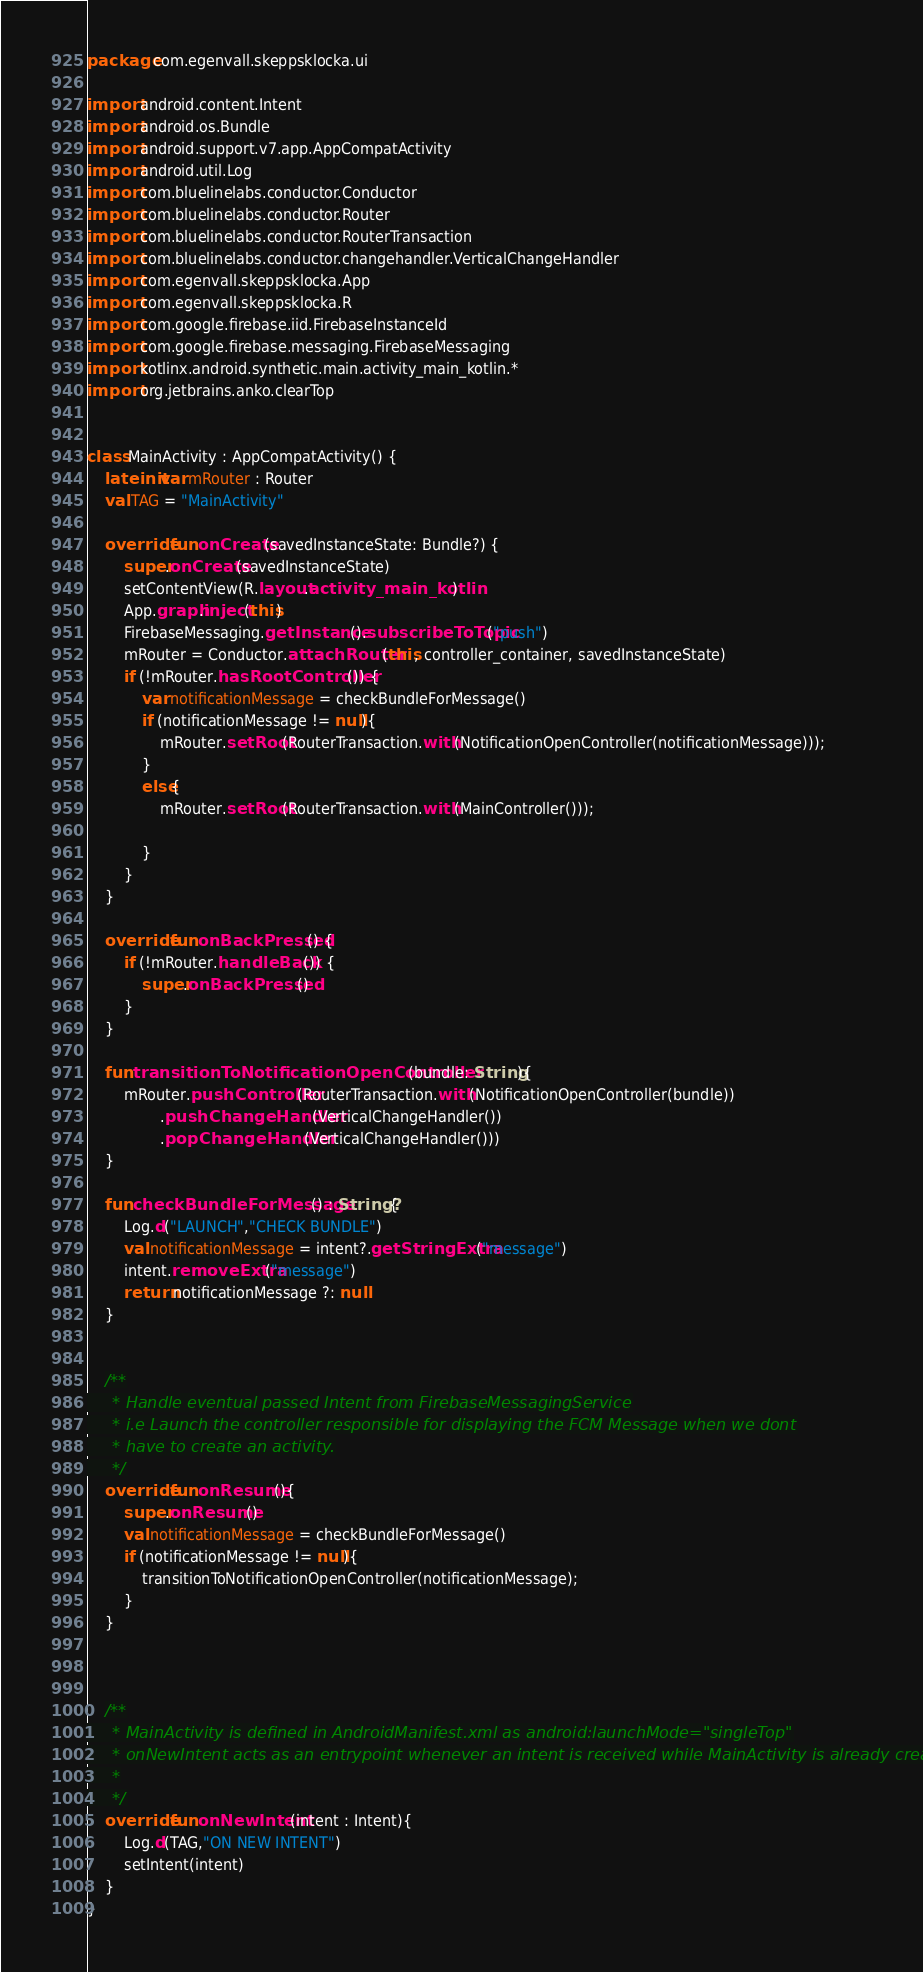<code> <loc_0><loc_0><loc_500><loc_500><_Kotlin_>package com.egenvall.skeppsklocka.ui

import android.content.Intent
import android.os.Bundle
import android.support.v7.app.AppCompatActivity
import android.util.Log
import com.bluelinelabs.conductor.Conductor
import com.bluelinelabs.conductor.Router
import com.bluelinelabs.conductor.RouterTransaction
import com.bluelinelabs.conductor.changehandler.VerticalChangeHandler
import com.egenvall.skeppsklocka.App
import com.egenvall.skeppsklocka.R
import com.google.firebase.iid.FirebaseInstanceId
import com.google.firebase.messaging.FirebaseMessaging
import kotlinx.android.synthetic.main.activity_main_kotlin.*
import org.jetbrains.anko.clearTop


class MainActivity : AppCompatActivity() {
    lateinit var mRouter : Router
    val TAG = "MainActivity"

    override fun onCreate(savedInstanceState: Bundle?) {
        super.onCreate(savedInstanceState)
        setContentView(R.layout.activity_main_kotlin)
        App.graph.inject(this)
        FirebaseMessaging.getInstance().subscribeToTopic("push")
        mRouter = Conductor.attachRouter(this, controller_container, savedInstanceState)
        if (!mRouter.hasRootController()) {
            var notificationMessage = checkBundleForMessage()
            if (notificationMessage != null){
                mRouter.setRoot(RouterTransaction.with(NotificationOpenController(notificationMessage)));
            }
            else{
                mRouter.setRoot(RouterTransaction.with(MainController()));

            }
        }
    }

    override fun onBackPressed() {
        if (!mRouter.handleBack()) {
            super.onBackPressed()
        }
    }

    fun transitionToNotificationOpenController(bundle: String){
        mRouter.pushController(RouterTransaction.with(NotificationOpenController(bundle))
                .pushChangeHandler(VerticalChangeHandler())
                .popChangeHandler(VerticalChangeHandler()))
    }

    fun checkBundleForMessage() : String?{
        Log.d("LAUNCH","CHECK BUNDLE")
        val notificationMessage = intent?.getStringExtra("message")
        intent.removeExtra("message")
        return notificationMessage ?: null
    }


    /**
     * Handle eventual passed Intent from FirebaseMessagingService
     * i.e Launch the controller responsible for displaying the FCM Message when we dont
     * have to create an activity.
     */
    override fun onResume(){
        super.onResume()
        val notificationMessage = checkBundleForMessage()
        if (notificationMessage != null){
            transitionToNotificationOpenController(notificationMessage);
        }
    }



    /**
     * MainActivity is defined in AndroidManifest.xml as android:launchMode="singleTop"
     * onNewIntent acts as an entrypoint whenever an intent is received while MainActivity is already created.
     *
     */
    override fun onNewIntent(intent : Intent){
        Log.d(TAG,"ON NEW INTENT")
        setIntent(intent)
    }
}
</code> 